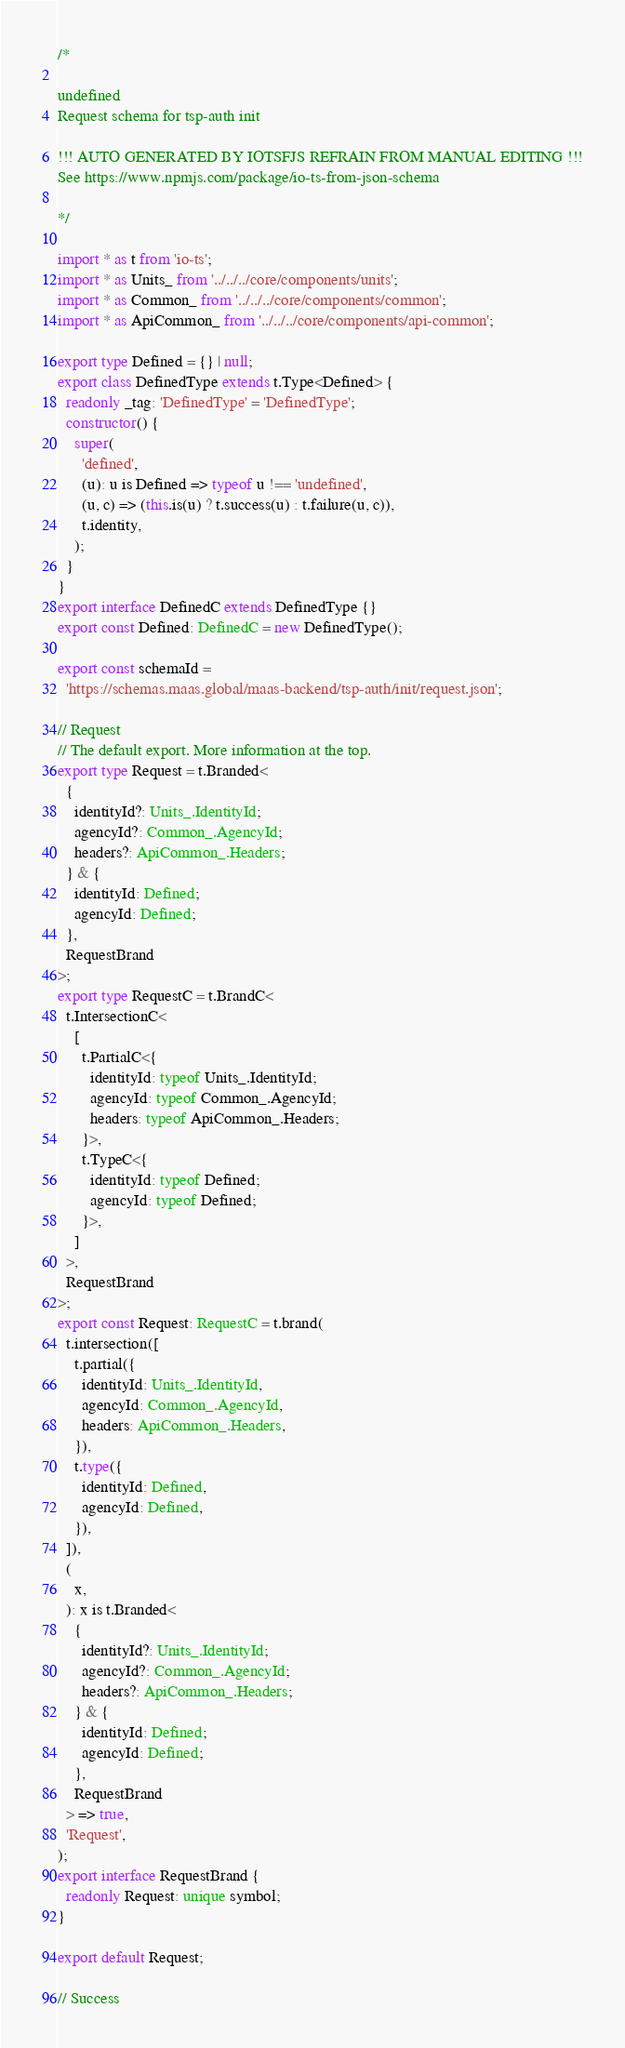Convert code to text. <code><loc_0><loc_0><loc_500><loc_500><_TypeScript_>/*

undefined
Request schema for tsp-auth init

!!! AUTO GENERATED BY IOTSFJS REFRAIN FROM MANUAL EDITING !!!
See https://www.npmjs.com/package/io-ts-from-json-schema

*/

import * as t from 'io-ts';
import * as Units_ from '../../../core/components/units';
import * as Common_ from '../../../core/components/common';
import * as ApiCommon_ from '../../../core/components/api-common';

export type Defined = {} | null;
export class DefinedType extends t.Type<Defined> {
  readonly _tag: 'DefinedType' = 'DefinedType';
  constructor() {
    super(
      'defined',
      (u): u is Defined => typeof u !== 'undefined',
      (u, c) => (this.is(u) ? t.success(u) : t.failure(u, c)),
      t.identity,
    );
  }
}
export interface DefinedC extends DefinedType {}
export const Defined: DefinedC = new DefinedType();

export const schemaId =
  'https://schemas.maas.global/maas-backend/tsp-auth/init/request.json';

// Request
// The default export. More information at the top.
export type Request = t.Branded<
  {
    identityId?: Units_.IdentityId;
    agencyId?: Common_.AgencyId;
    headers?: ApiCommon_.Headers;
  } & {
    identityId: Defined;
    agencyId: Defined;
  },
  RequestBrand
>;
export type RequestC = t.BrandC<
  t.IntersectionC<
    [
      t.PartialC<{
        identityId: typeof Units_.IdentityId;
        agencyId: typeof Common_.AgencyId;
        headers: typeof ApiCommon_.Headers;
      }>,
      t.TypeC<{
        identityId: typeof Defined;
        agencyId: typeof Defined;
      }>,
    ]
  >,
  RequestBrand
>;
export const Request: RequestC = t.brand(
  t.intersection([
    t.partial({
      identityId: Units_.IdentityId,
      agencyId: Common_.AgencyId,
      headers: ApiCommon_.Headers,
    }),
    t.type({
      identityId: Defined,
      agencyId: Defined,
    }),
  ]),
  (
    x,
  ): x is t.Branded<
    {
      identityId?: Units_.IdentityId;
      agencyId?: Common_.AgencyId;
      headers?: ApiCommon_.Headers;
    } & {
      identityId: Defined;
      agencyId: Defined;
    },
    RequestBrand
  > => true,
  'Request',
);
export interface RequestBrand {
  readonly Request: unique symbol;
}

export default Request;

// Success
</code> 